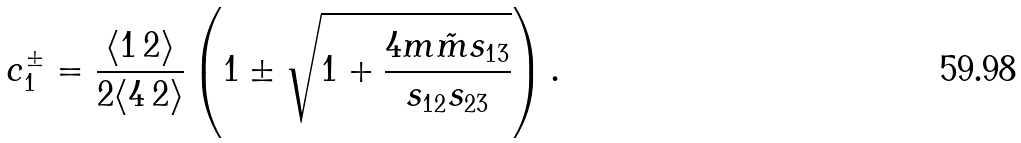Convert formula to latex. <formula><loc_0><loc_0><loc_500><loc_500>c _ { 1 } ^ { \pm } = \frac { \langle 1 \, 2 \rangle } { 2 \langle 4 \, 2 \rangle } \left ( 1 \pm \sqrt { 1 + \frac { 4 m \tilde { m } s _ { 1 3 } } { s _ { 1 2 } s _ { 2 3 } } } \right ) .</formula> 